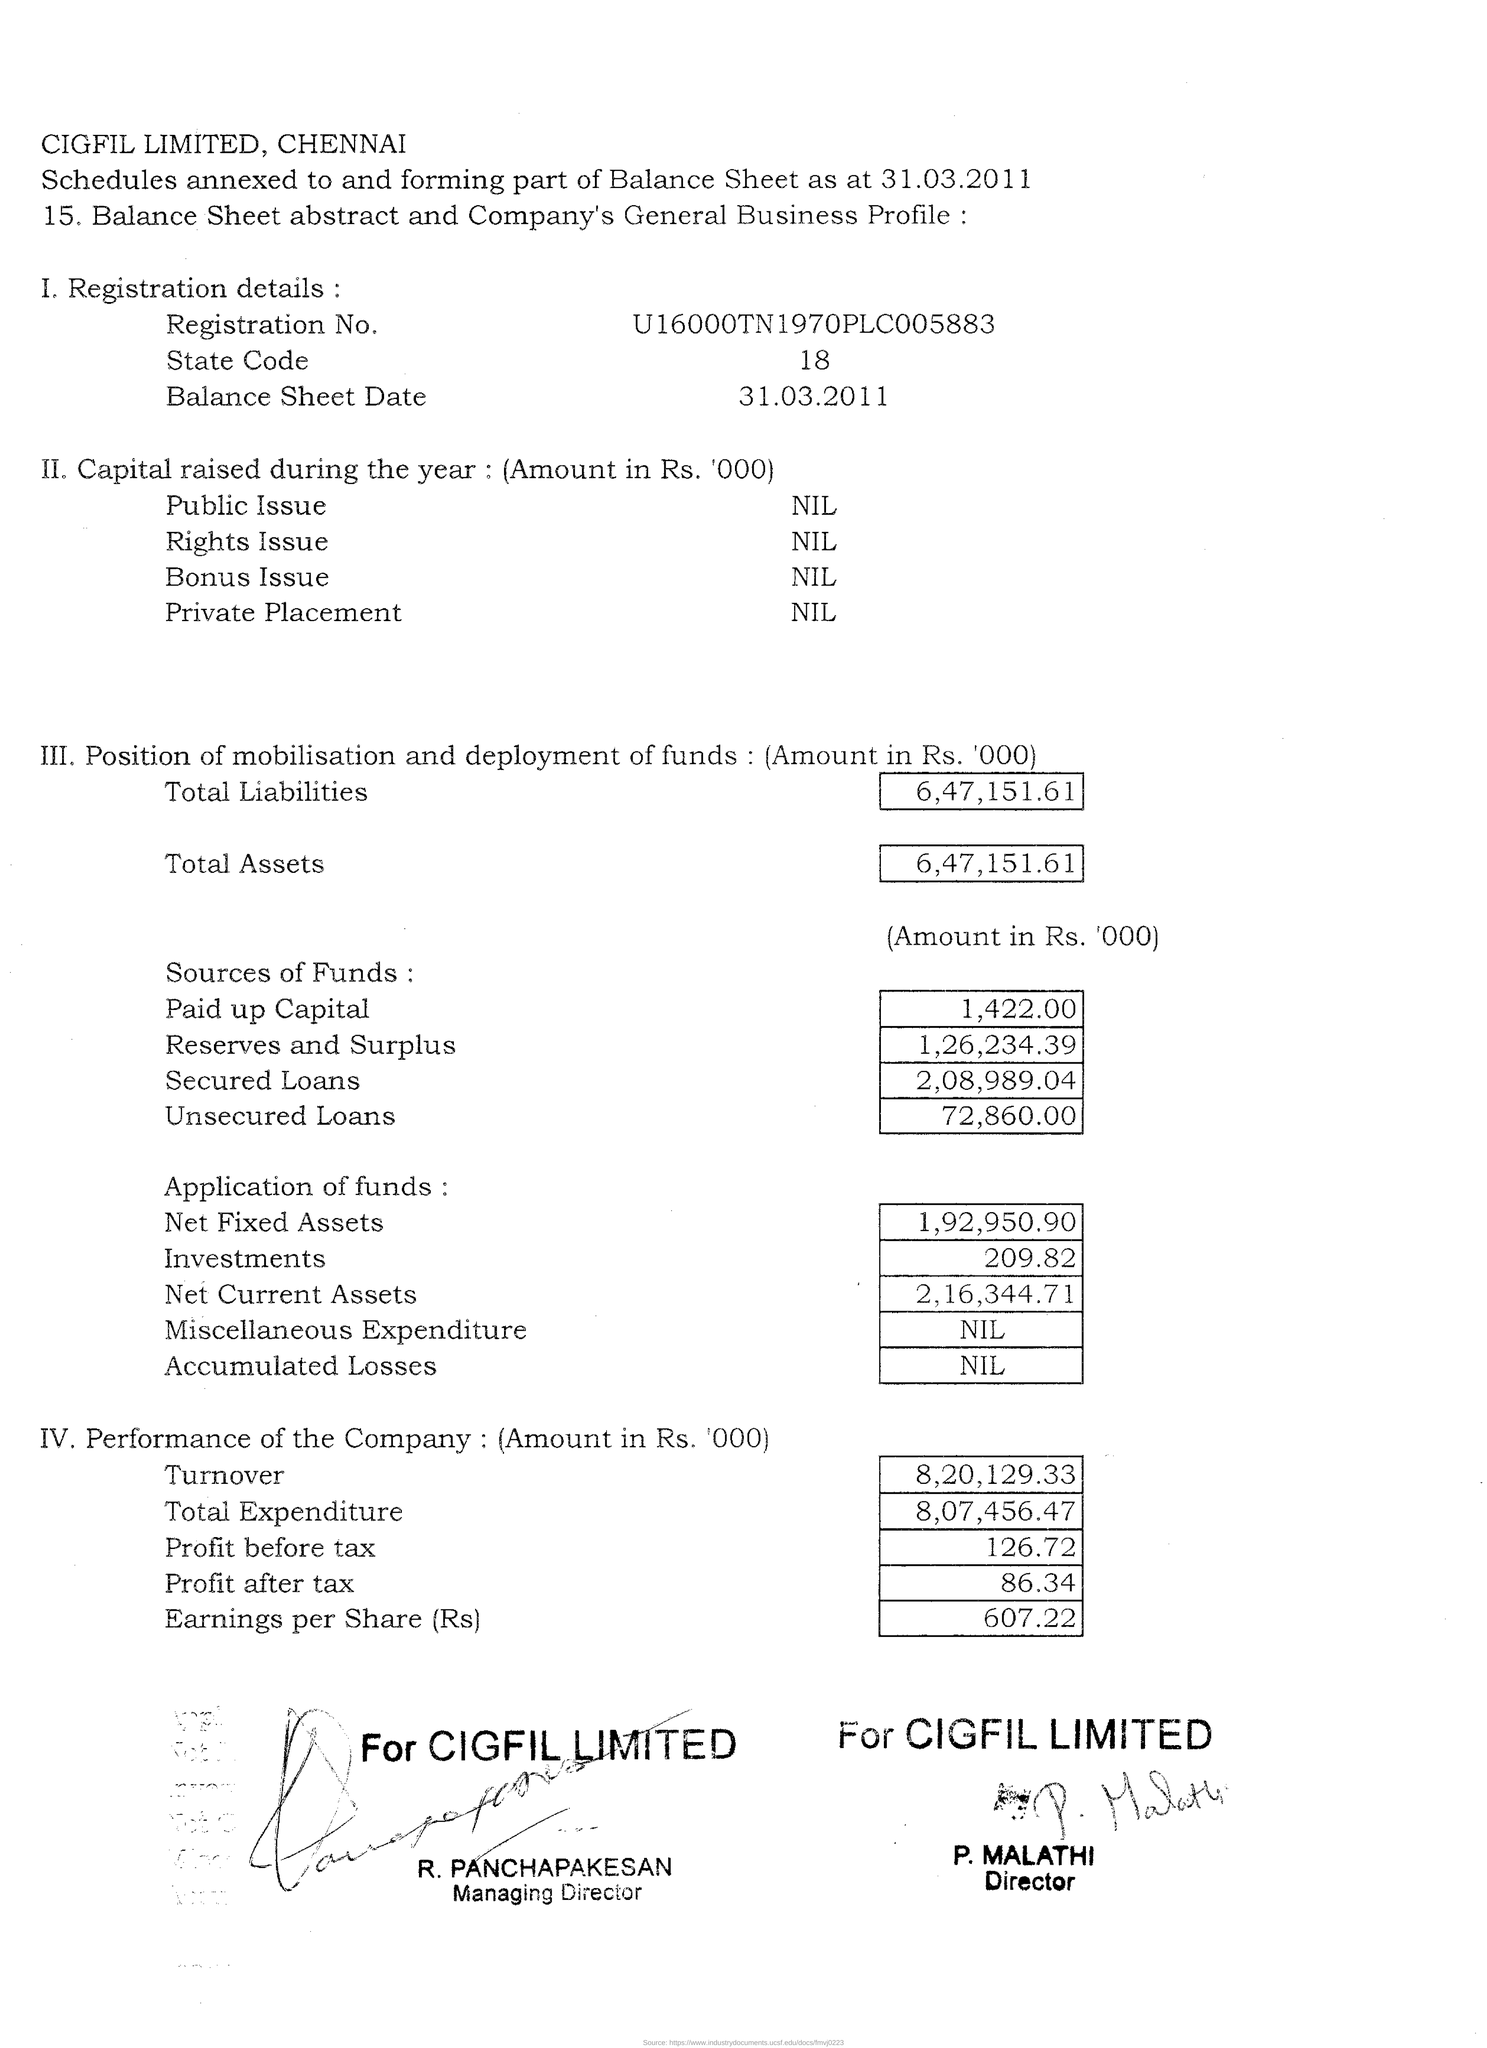What is the company's registration no?
Make the answer very short. U16000TN1970PLC005883. What is the state code?
Keep it short and to the point. 18. What is the balance sheet date?
Offer a terse response. 31.03.2011. How  much is the total liability mentioned in '000?
Your response must be concise. 6,47,151.61. How much is the total assets mentioned in '000?
Offer a very short reply. 6,47,151.61. What is the earnings per share?
Ensure brevity in your answer.  607.22. What is the turn over of the company?
Offer a very short reply. 8,20,129.33. What is the total expenditure of the company?
Your answer should be compact. 8,07,456.47. 